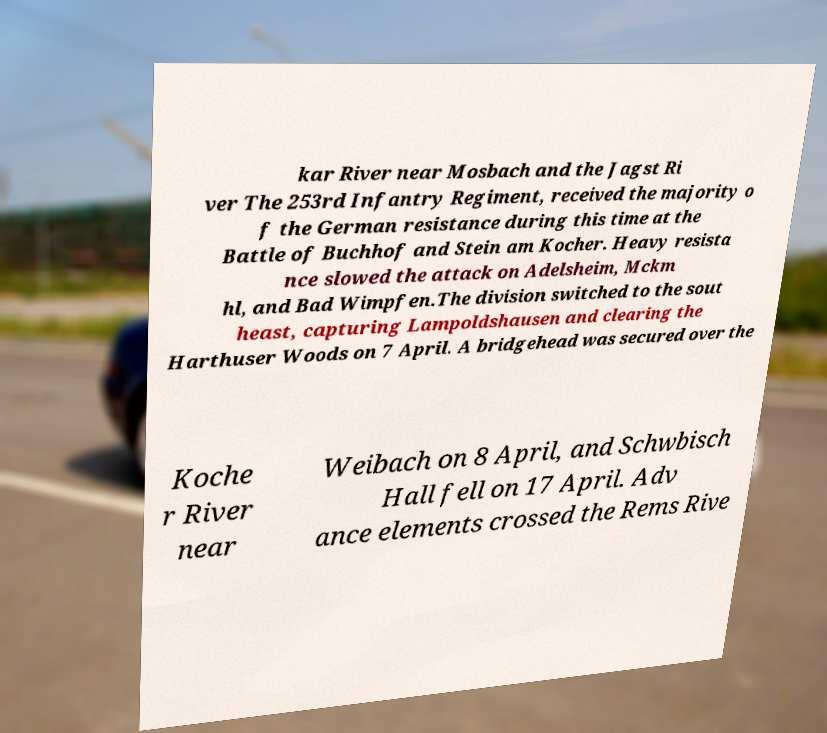Could you extract and type out the text from this image? kar River near Mosbach and the Jagst Ri ver The 253rd Infantry Regiment, received the majority o f the German resistance during this time at the Battle of Buchhof and Stein am Kocher. Heavy resista nce slowed the attack on Adelsheim, Mckm hl, and Bad Wimpfen.The division switched to the sout heast, capturing Lampoldshausen and clearing the Harthuser Woods on 7 April. A bridgehead was secured over the Koche r River near Weibach on 8 April, and Schwbisch Hall fell on 17 April. Adv ance elements crossed the Rems Rive 